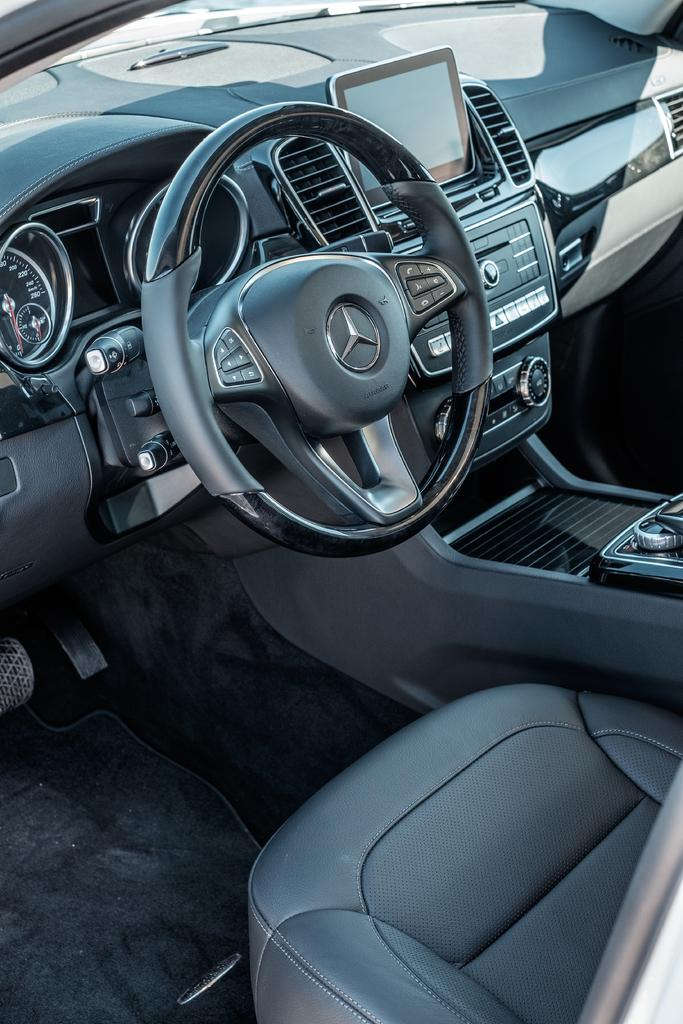What type of vehicle is shown in the image? The image shows the inside view of a car. What electronic device is present in the car? There is a screen in the car. What is used to control the direction of the car? There is a steering wheel in the car. What are the passengers sitting on in the car? There are seats in the car. Can you describe any other objects present in the car? There are other unspecified-specified objects in the car. What type of needle is used to make a selection on the screen in the car? There is no needle present in the image, and the screen does not require a needle for selection. 